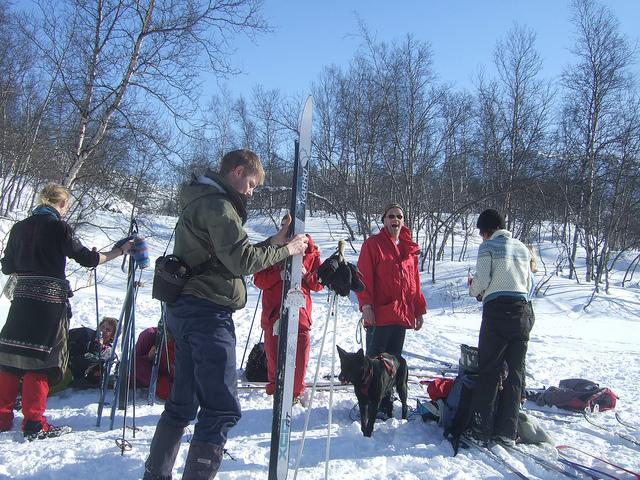What will the dog do?
Be succinct. Run. How many ski poles are in the picture?
Write a very short answer. 4. Are these people skiing?
Keep it brief. No. What is sticking out of the snow?
Quick response, please. Trees. 